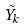Convert formula to latex. <formula><loc_0><loc_0><loc_500><loc_500>\tilde { Y _ { k } }</formula> 